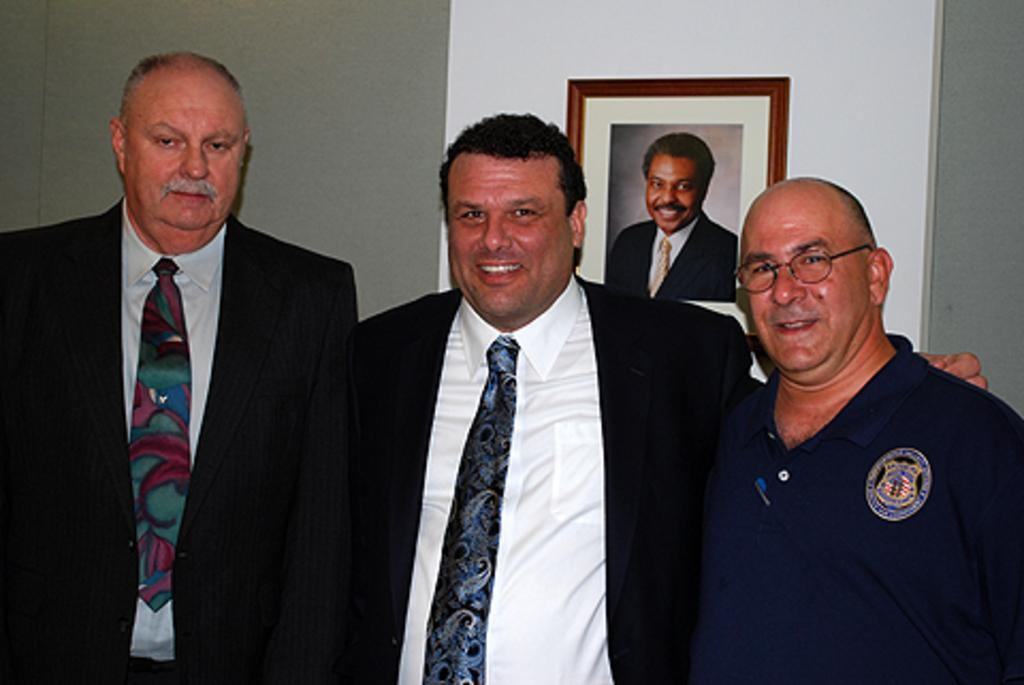How many people are in the image? There are three persons in the image. What are the persons doing in the image? The persons are standing and smiling. Can you describe anything in the background of the image? There is a photo frame hanging on the wall in the background of the image. What type of afterthought can be seen in the image? There is no afterthought present in the image; it features three persons standing and smiling. How does the system work in the image? There is no system present in the image; it is a simple scene of three persons standing and smiling. 